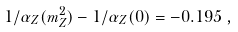<formula> <loc_0><loc_0><loc_500><loc_500>1 / \alpha _ { Z } ( m _ { Z } ^ { 2 } ) - 1 / \alpha _ { Z } ( 0 ) = - 0 . 1 9 5 \, ,</formula> 